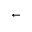Convert formula to latex. <formula><loc_0><loc_0><loc_500><loc_500>\leftarrow</formula> 